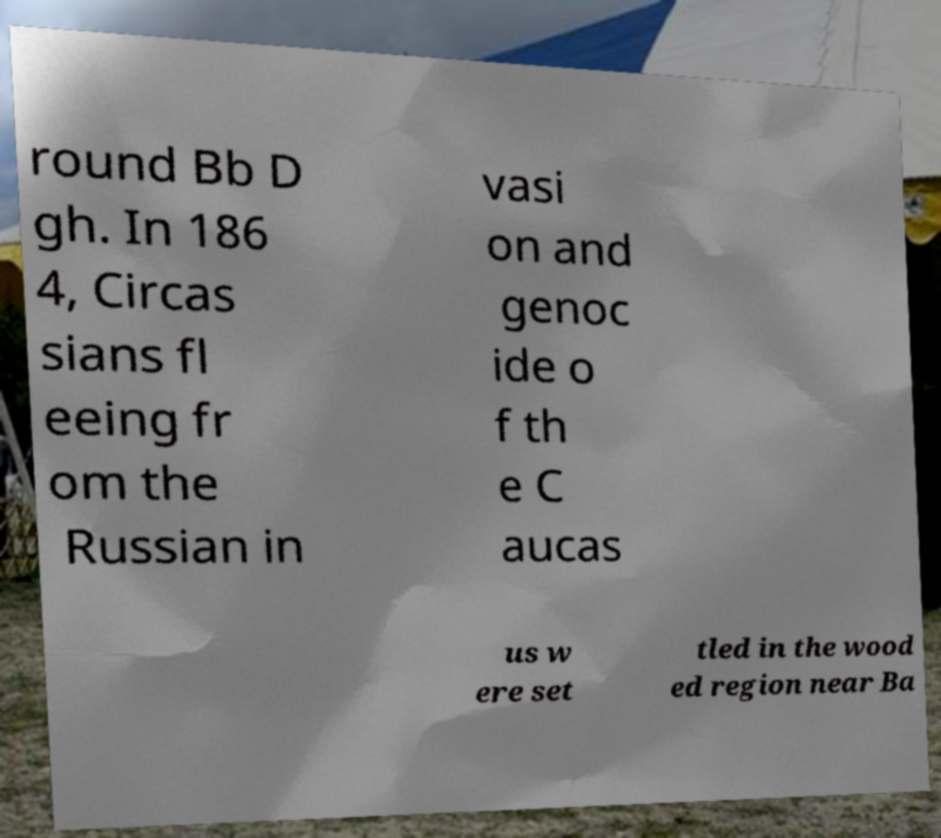Could you assist in decoding the text presented in this image and type it out clearly? round Bb D gh. In 186 4, Circas sians fl eeing fr om the Russian in vasi on and genoc ide o f th e C aucas us w ere set tled in the wood ed region near Ba 